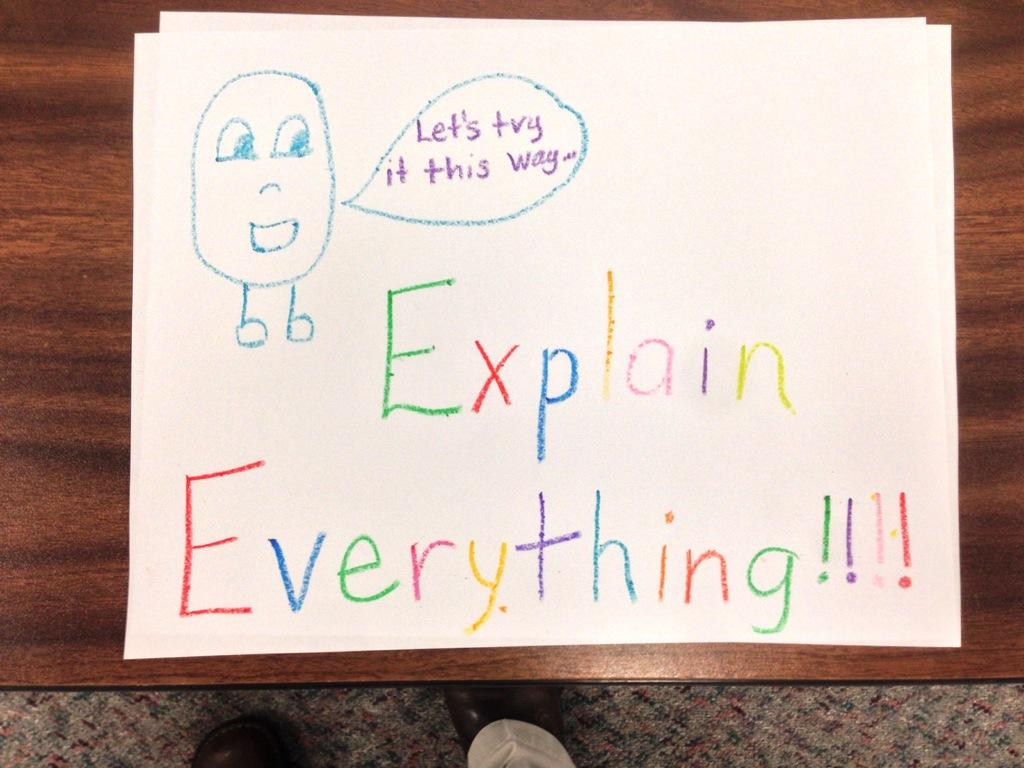<image>
Provide a brief description of the given image. A sign with many colors saying to explain everything 